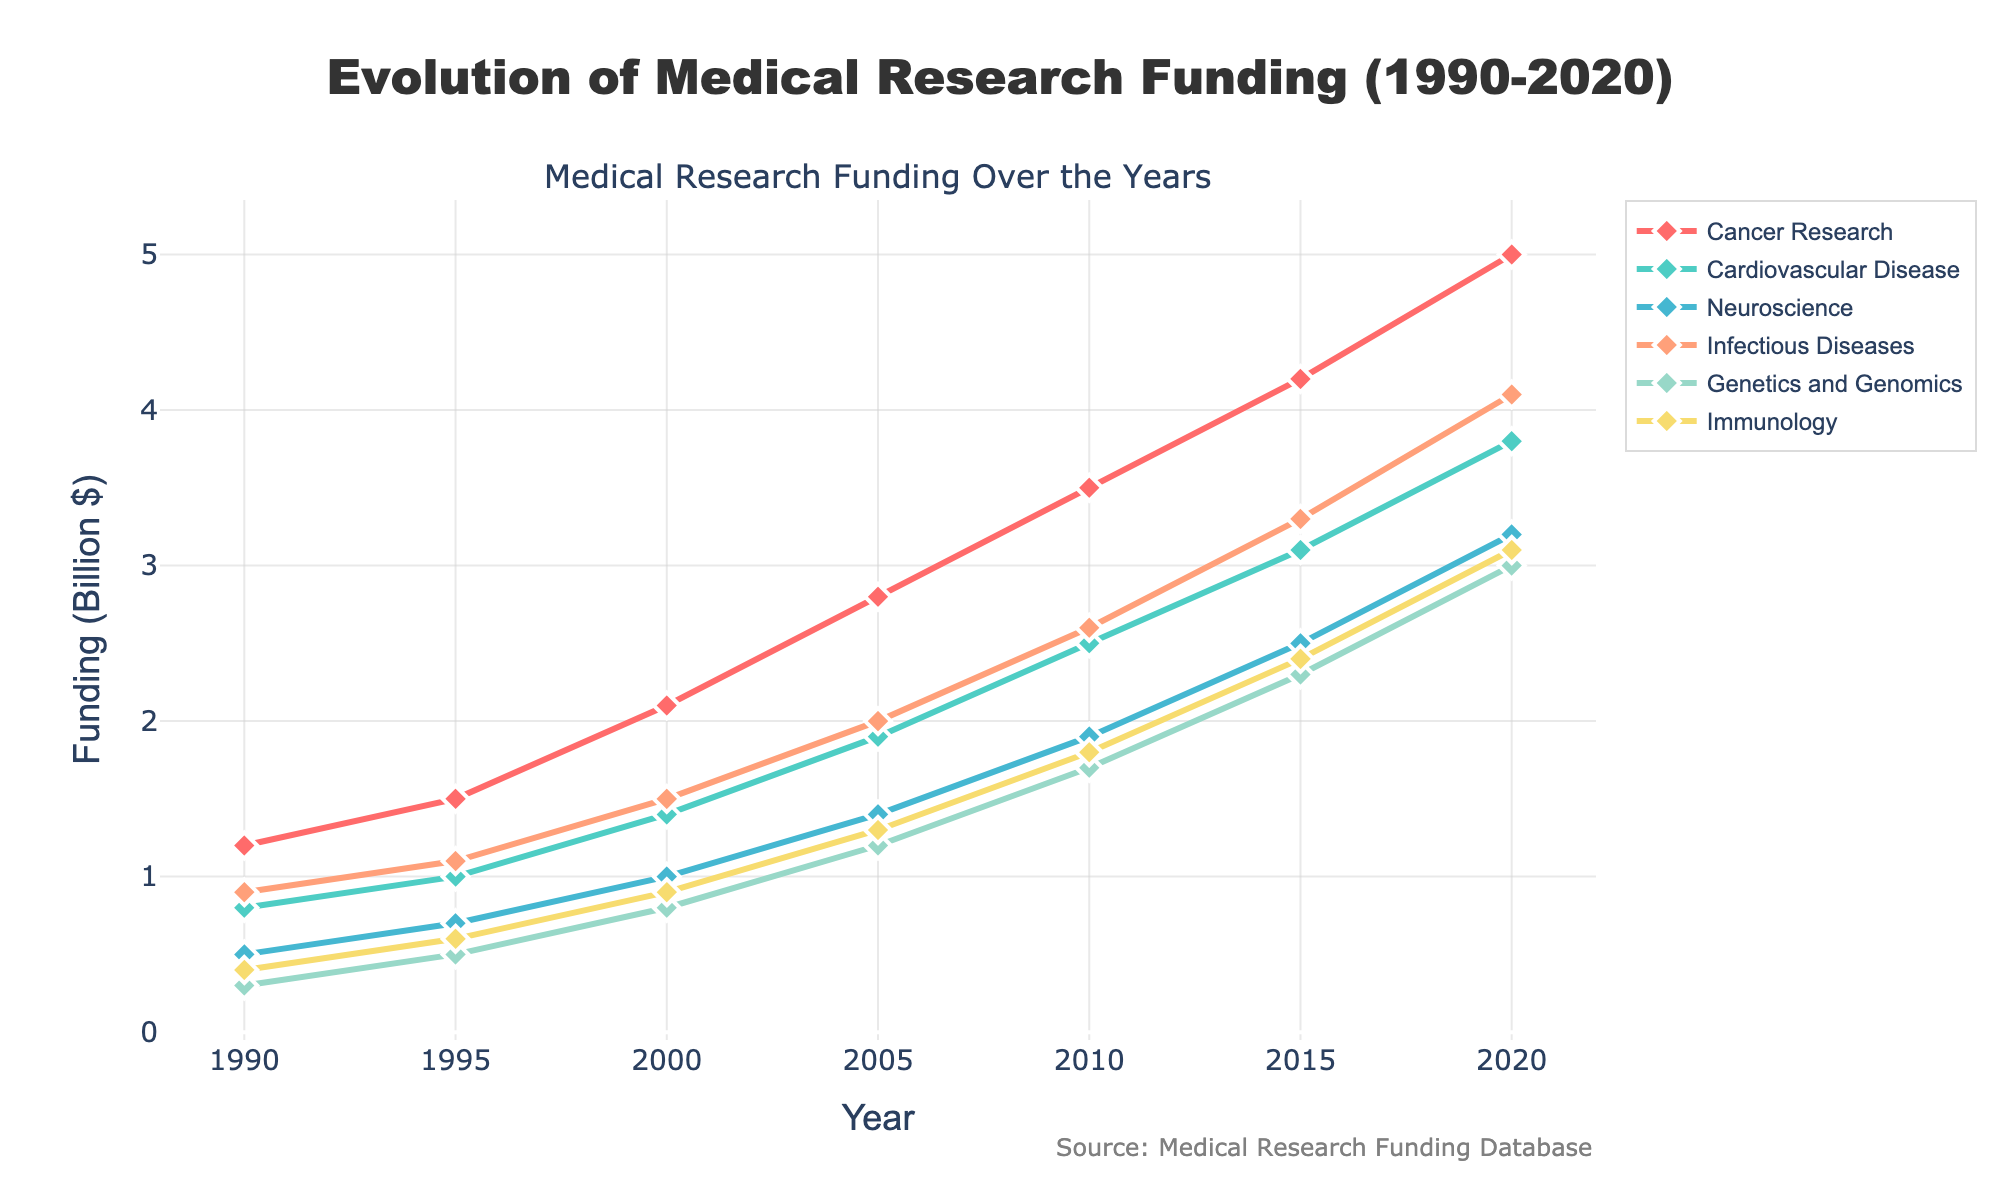What's the field with the highest funding in 2020? To find the field with the highest funding in 2020, look at the endpoint (year 2020) of each line on the plot and identify which point is the highest. The Cancer Research line appears at the top at this year.
Answer: Cancer Research How much did funding for Neuroscience increase from 1990 to 2020? To determine the increase in funding for Neuroscience from 1990 to 2020, subtract the 1990 value from the 2020 value. According to the data, it's 3.2 billion in 2020 minus 0.5 billion in 1990.
Answer: 2.7 billion Which funding area saw the largest increase between 2010 and 2020? To identify the funding area with the largest increase between 2010 and 2020, calculate the difference for each field by subtracting the 2010 value from the 2020 value. The funding increments are:
Cancer Research: 5.0 - 3.5 = 1.5
Cardiovascular Disease: 3.8 - 2.5 = 1.3
Neuroscience: 3.2 - 1.9 = 1.3
Infectious Diseases: 4.1 - 2.6 = 1.5
Genetics and Genomics: 3.0 - 1.7 = 1.3
Immunology: 3.1 - 1.8 = 1.3. Both Cancer Research and Infectious Diseases have the largest increase by 1.5 billion.
Answer: Cancer Research and Infectious Diseases What is the total funding allocated for all fields in 1995? To find the total funding for all fields in 1995, sum the funding values for all fields in that year. The values are 1.5 (Cancer Research) + 1.0 (Cardiovascular Disease) + 0.7 (Neuroscience) + 1.1 (Infectious Diseases) + 0.5 (Genetics and Genomics) + 0.6 (Immunology) = 5.4 billion dollars.
Answer: 5.4 billion dollars Which field had the smallest increase in funding from 1990 to 2020? To determine which field had the smallest increase, subtract the 1990 values from the 2020 values for each field:
Cancer Research: 5.0 - 1.2 = 3.8
Cardiovascular Disease: 3.8 - 0.8 = 3.0
Neuroscience: 3.2 - 0.5 = 2.7
Infectious Diseases: 4.1 - 0.9 = 3.2
Genetics and Genomics: 3.0 - 0.3 = 2.7
Immunology: 3.1 - 0.4 = 2.7
Neuroscience, Genetics and Genomics, and Immunology have the smallest increase by 2.7 billion.
Answer: Neuroscience, Genetics and Genomics, and Immunology In which years did Infectious Diseases funding surpass Cardiovascular Disease funding? Look at the plot and identify the years where the Infectious Diseases line (orange) is above the Cardiovascular Disease line (green). From the visual, these years are 1995, 2000, 2005, 2010, 2015, and 2020.
Answer: 1995, 2000, 2005, 2010, 2015, 2020 Compare the figures for Cancer Research and Immunology in 2010, which received more funding and by how much? Look at the funding values for Cancer Research and Immunology in 2010. Cancer Research got 3.5 billion and Immunology got 1.8 billion. Subtract the lower amount from the higher amount: 3.5 - 1.8 = 1.7 billion.
Answer: Cancer Research, 1.7 billion 